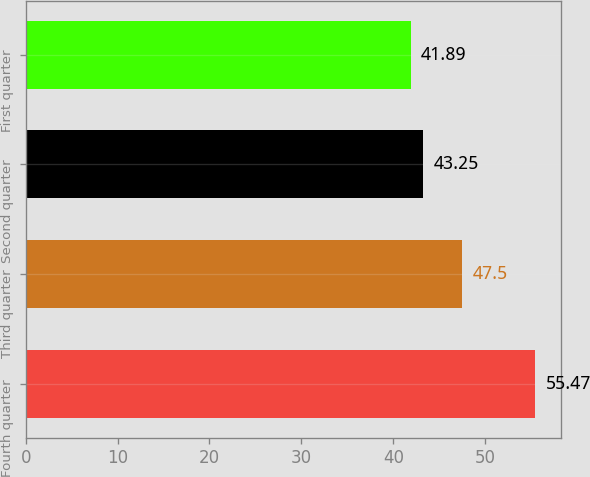<chart> <loc_0><loc_0><loc_500><loc_500><bar_chart><fcel>Fourth quarter<fcel>Third quarter<fcel>Second quarter<fcel>First quarter<nl><fcel>55.47<fcel>47.5<fcel>43.25<fcel>41.89<nl></chart> 